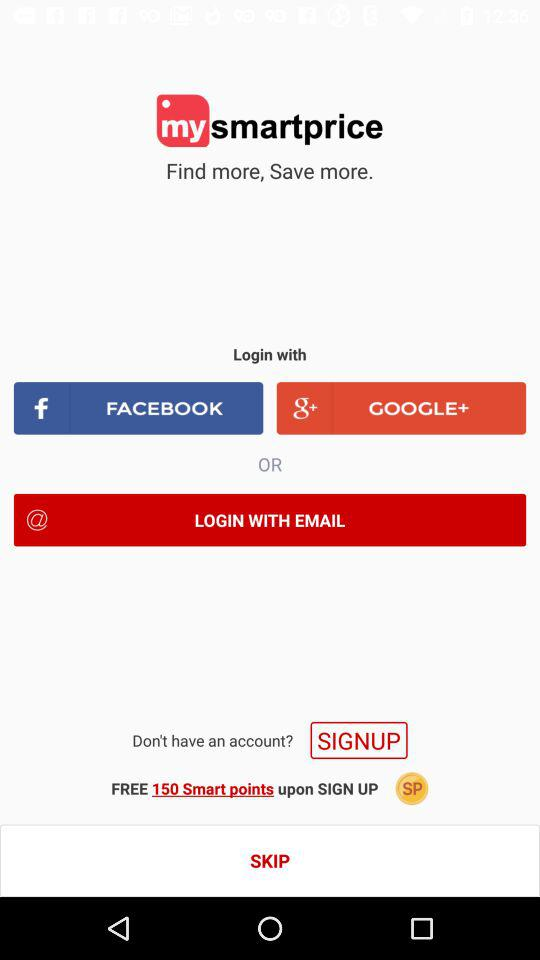What accounts can I use to sign up? You can use "FACEBOOK", "GOOGLE+" and "EMAIL" to sign up. 